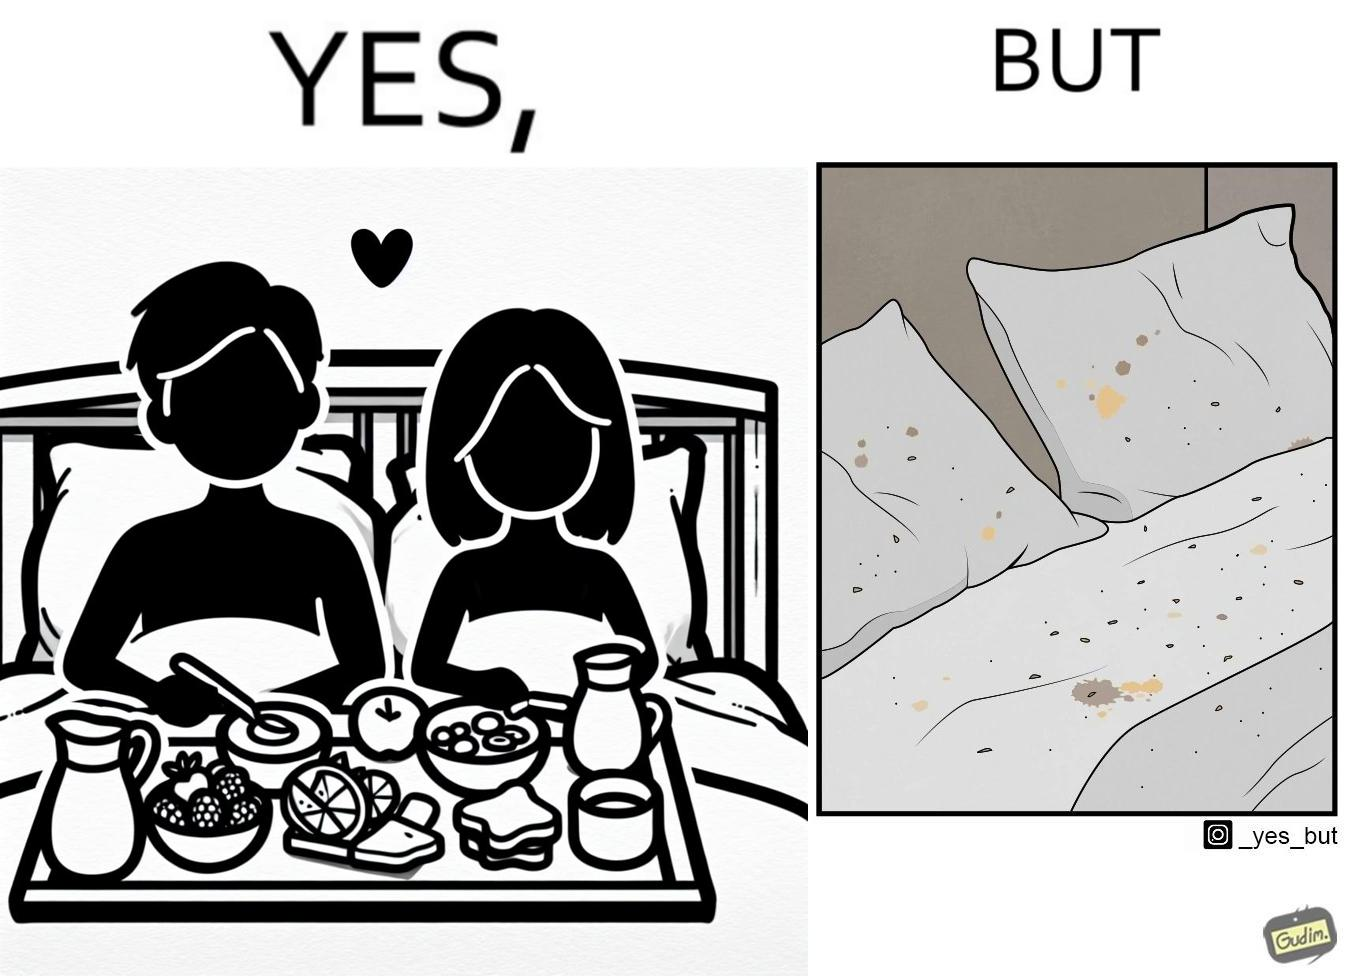What makes this image funny or satirical? The image is ironical, as having breakfast in bed is a luxury. However, eating while in bed leads to food crumbs, making the bed dirty, along with the need to clean the bed afterwards. 